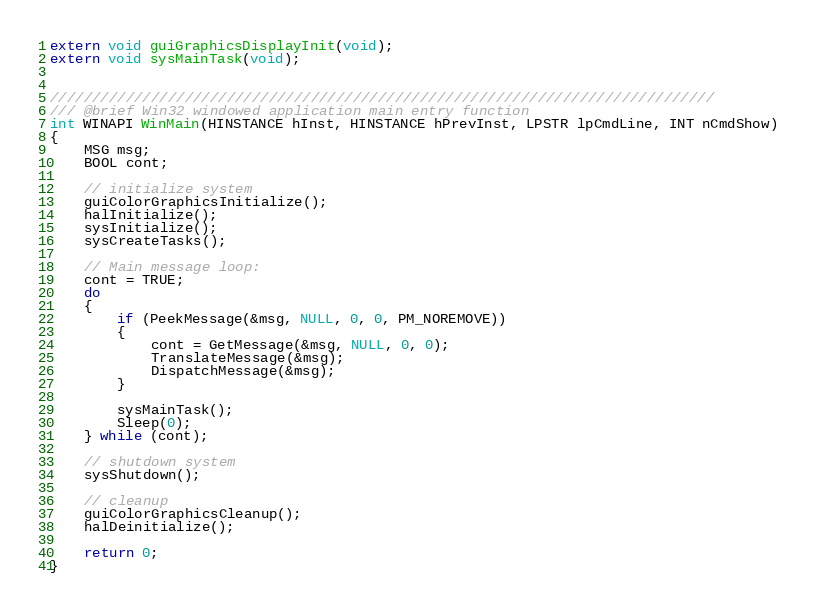<code> <loc_0><loc_0><loc_500><loc_500><_C_>extern void guiGraphicsDisplayInit(void);
extern void sysMainTask(void);


///////////////////////////////////////////////////////////////////////////////
/// @brief Win32 windowed application main entry function
int WINAPI WinMain(HINSTANCE hInst, HINSTANCE hPrevInst, LPSTR lpCmdLine, INT nCmdShow)
{
	MSG msg;
	BOOL cont;

	// initialize system
	guiColorGraphicsInitialize();
	halInitialize();
	sysInitialize();
	sysCreateTasks();

	// Main message loop:
	cont = TRUE;
	do
	{
		if (PeekMessage(&msg, NULL, 0, 0, PM_NOREMOVE))
		{
			cont = GetMessage(&msg, NULL, 0, 0);
			TranslateMessage(&msg);
			DispatchMessage(&msg);
		}

		sysMainTask();
		Sleep(0);
	} while (cont);

	// shutdown system
	sysShutdown();

	// cleanup
	guiColorGraphicsCleanup();
	halDeinitialize();

	return 0;
}
</code> 